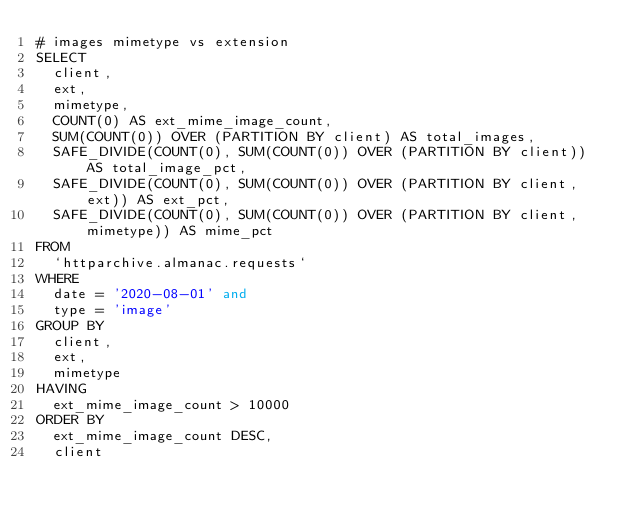<code> <loc_0><loc_0><loc_500><loc_500><_SQL_># images mimetype vs extension
SELECT
  client,
  ext,
  mimetype,
  COUNT(0) AS ext_mime_image_count,
  SUM(COUNT(0)) OVER (PARTITION BY client) AS total_images,
  SAFE_DIVIDE(COUNT(0), SUM(COUNT(0)) OVER (PARTITION BY client)) AS total_image_pct,
  SAFE_DIVIDE(COUNT(0), SUM(COUNT(0)) OVER (PARTITION BY client, ext)) AS ext_pct,
  SAFE_DIVIDE(COUNT(0), SUM(COUNT(0)) OVER (PARTITION BY client, mimetype)) AS mime_pct
FROM
  `httparchive.almanac.requests`
WHERE
  date = '2020-08-01' and
  type = 'image'
GROUP BY
  client,
  ext,
  mimetype
HAVING
  ext_mime_image_count > 10000
ORDER BY
  ext_mime_image_count DESC,
  client
</code> 